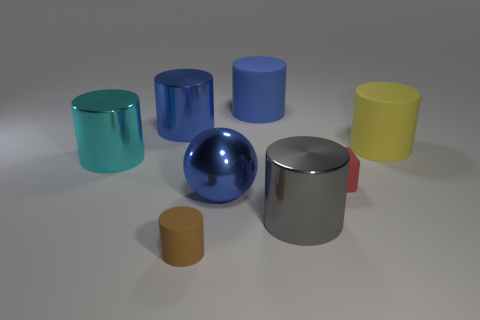What colors are the objects in the image? The objects in the image feature a variety of colors, including teal, blue, yellow, silver, and shades of brown and gray. Which object seems to reflect the most light? The spherical object in the center reflects the most light, giving it a shiny appearance. 